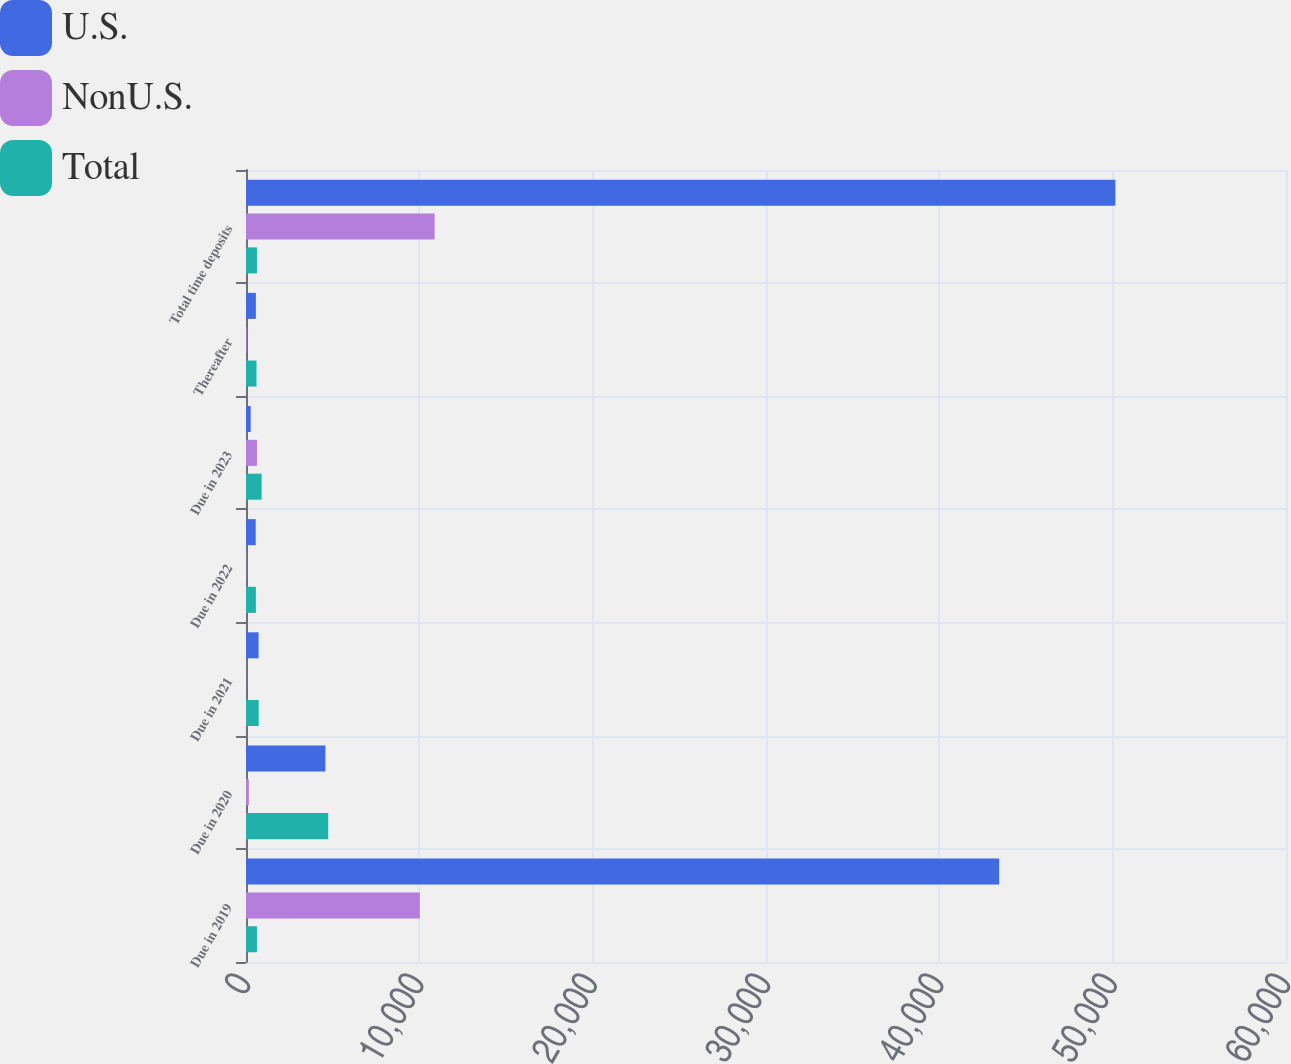Convert chart. <chart><loc_0><loc_0><loc_500><loc_500><stacked_bar_chart><ecel><fcel>Due in 2019<fcel>Due in 2020<fcel>Due in 2021<fcel>Due in 2022<fcel>Due in 2023<fcel>Thereafter<fcel>Total time deposits<nl><fcel>U.S.<fcel>43452<fcel>4580<fcel>725<fcel>560<fcel>270<fcel>570<fcel>50157<nl><fcel>NonU.S.<fcel>10030<fcel>164<fcel>8<fcel>11<fcel>632<fcel>37<fcel>10882<nl><fcel>Total<fcel>632<fcel>4744<fcel>733<fcel>571<fcel>902<fcel>607<fcel>632<nl></chart> 